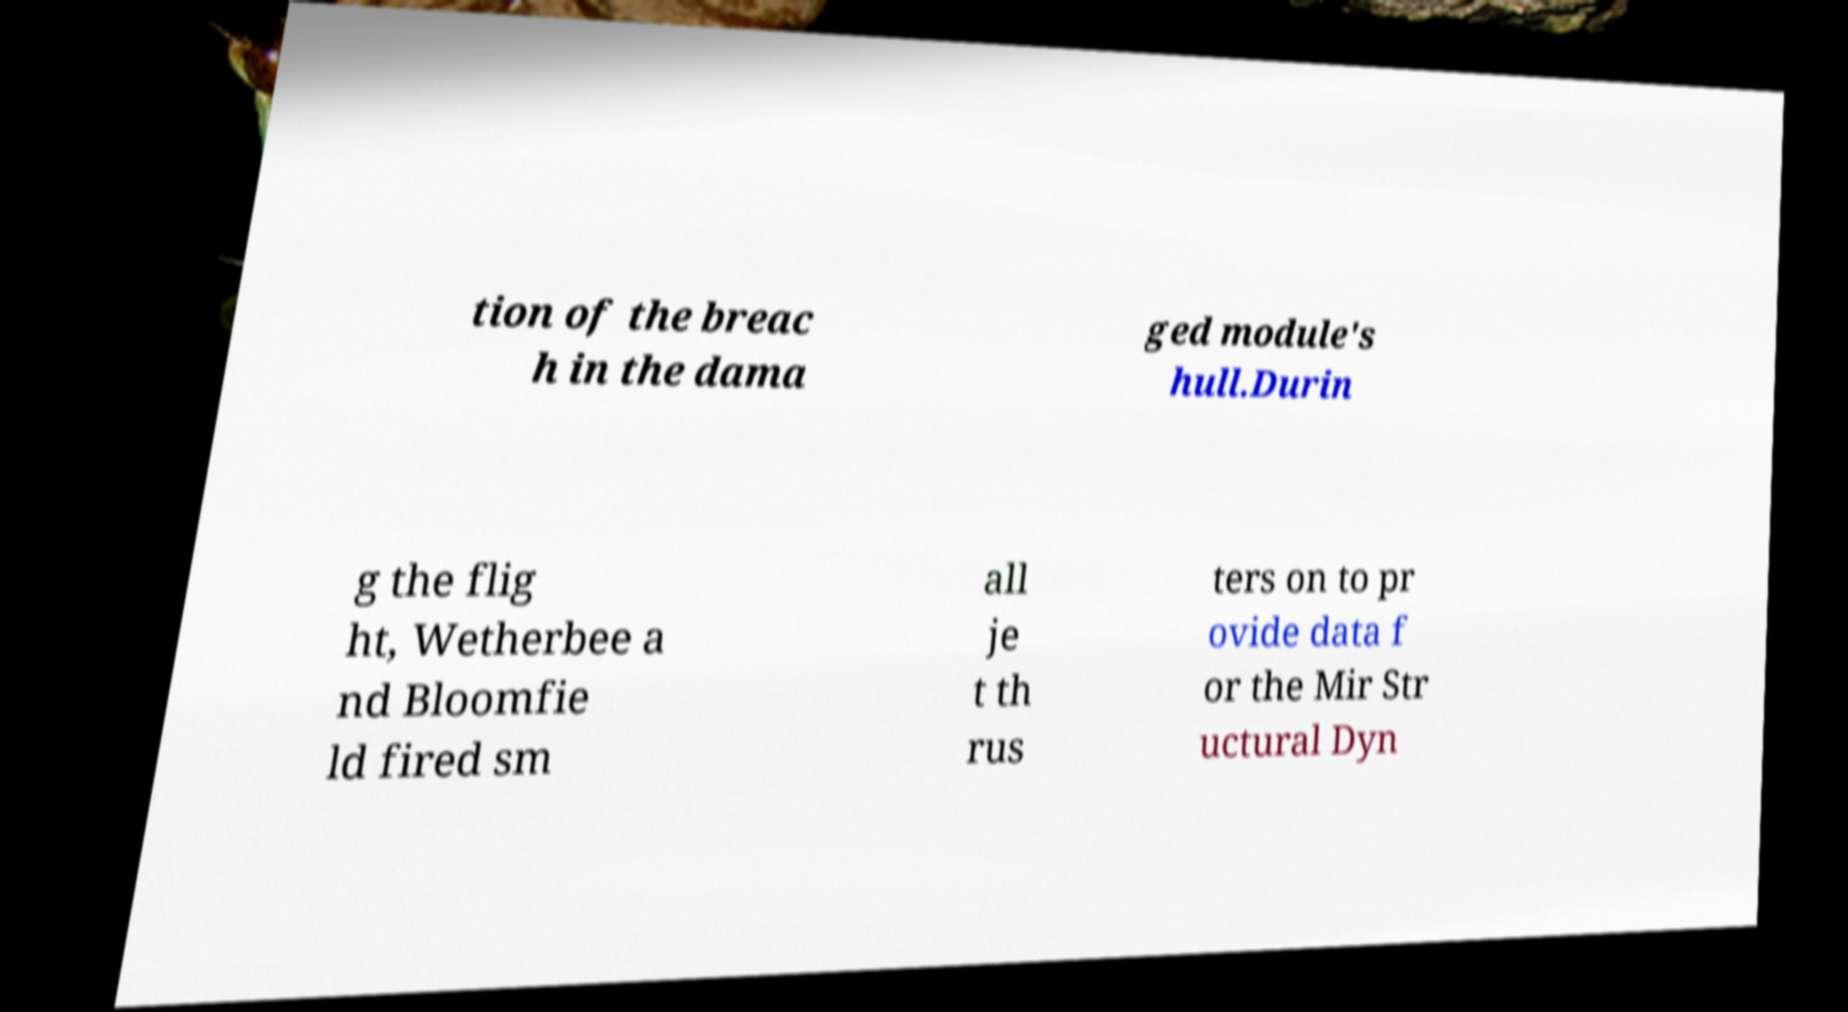Can you read and provide the text displayed in the image?This photo seems to have some interesting text. Can you extract and type it out for me? tion of the breac h in the dama ged module's hull.Durin g the flig ht, Wetherbee a nd Bloomfie ld fired sm all je t th rus ters on to pr ovide data f or the Mir Str uctural Dyn 